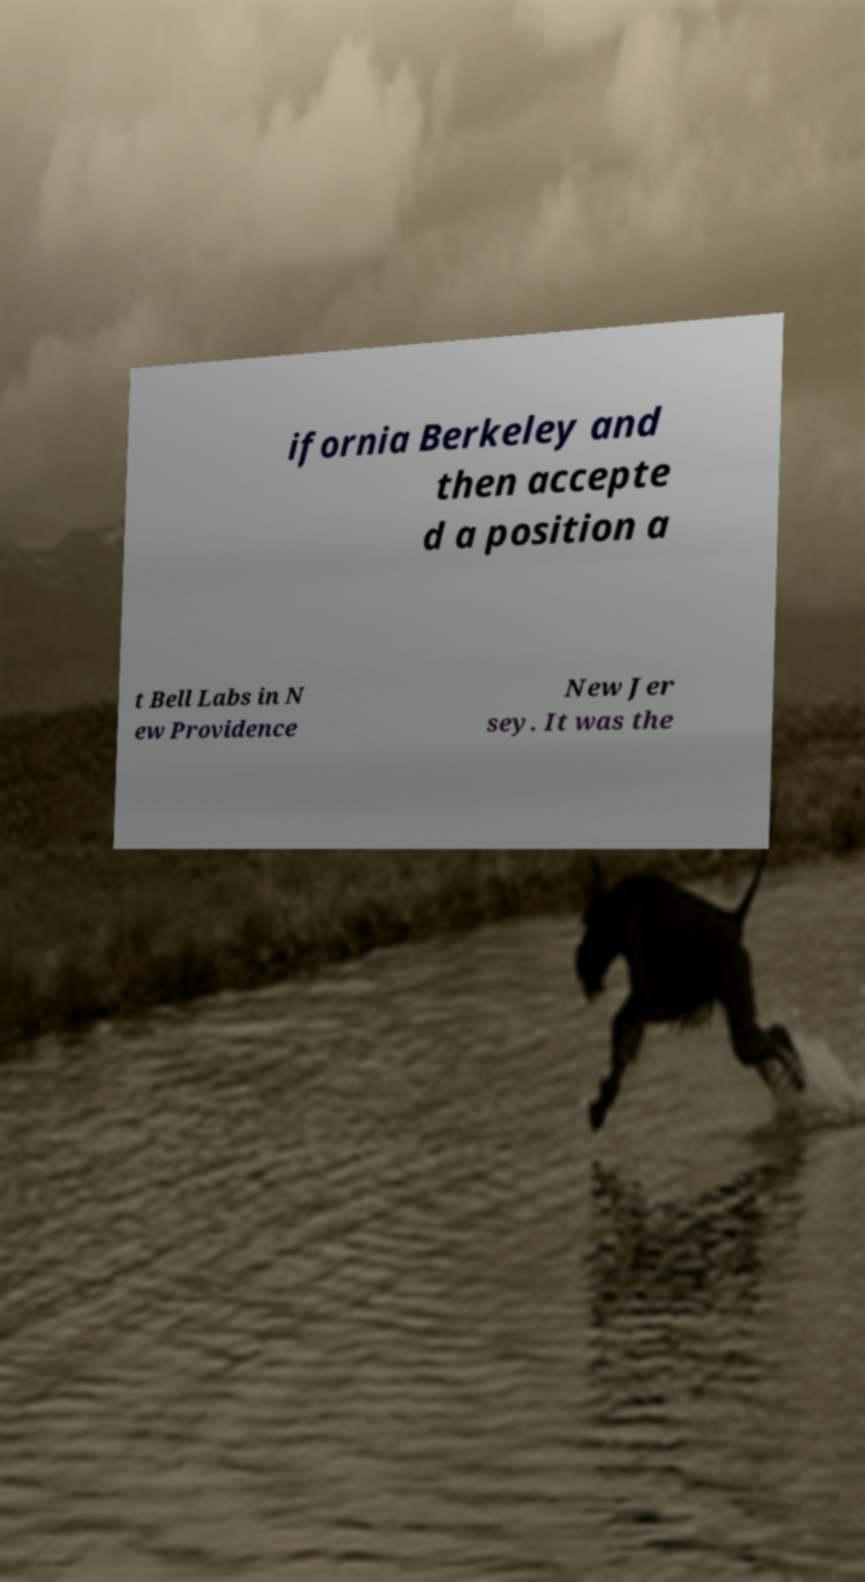There's text embedded in this image that I need extracted. Can you transcribe it verbatim? ifornia Berkeley and then accepte d a position a t Bell Labs in N ew Providence New Jer sey. It was the 